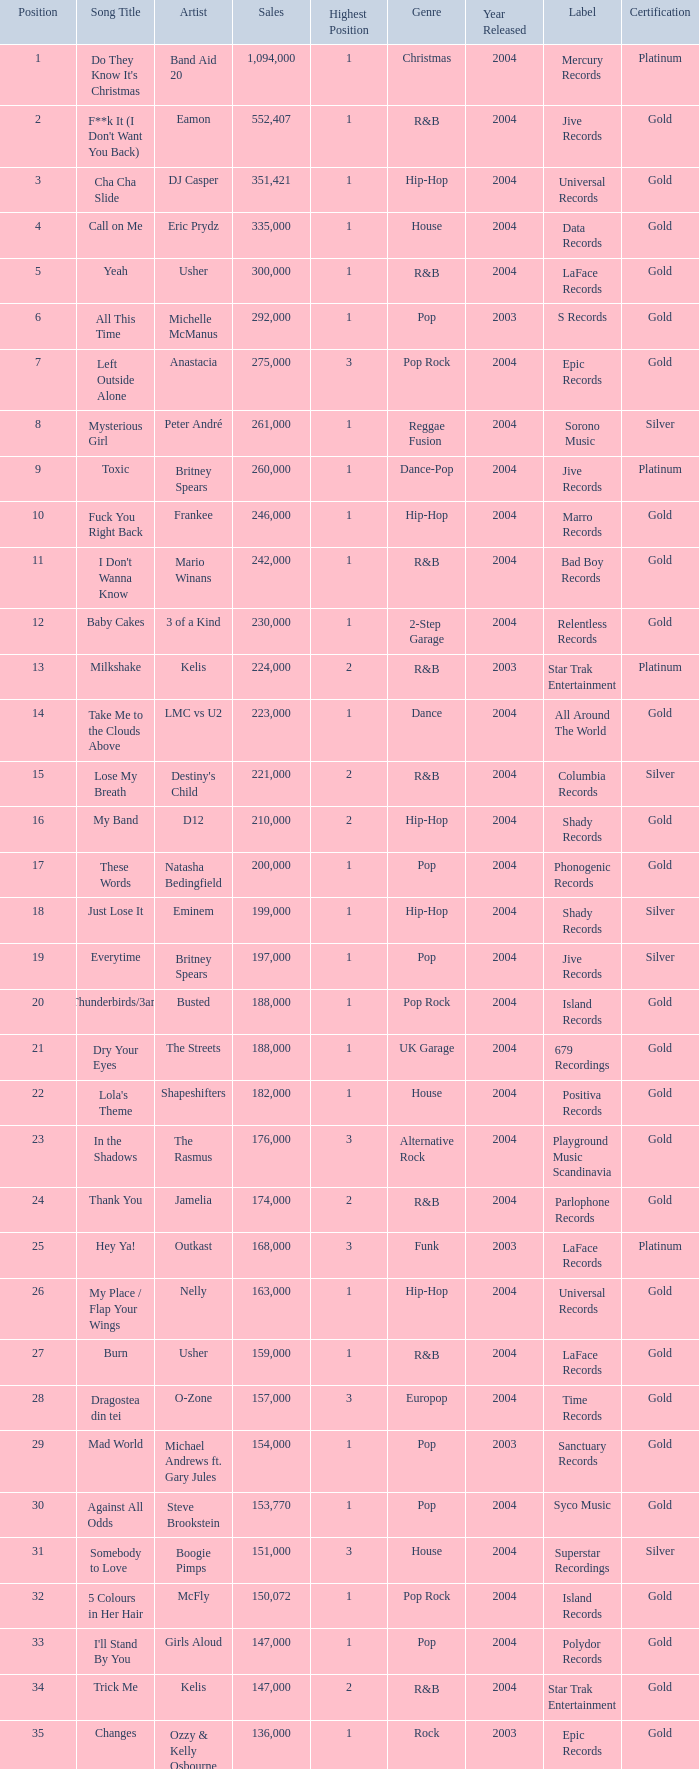What were the sales for Dj Casper when he was in a position lower than 13? 351421.0. 